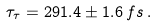<formula> <loc_0><loc_0><loc_500><loc_500>\tau _ { \tau } = 2 9 1 . 4 \pm 1 . 6 \, f s \, .</formula> 